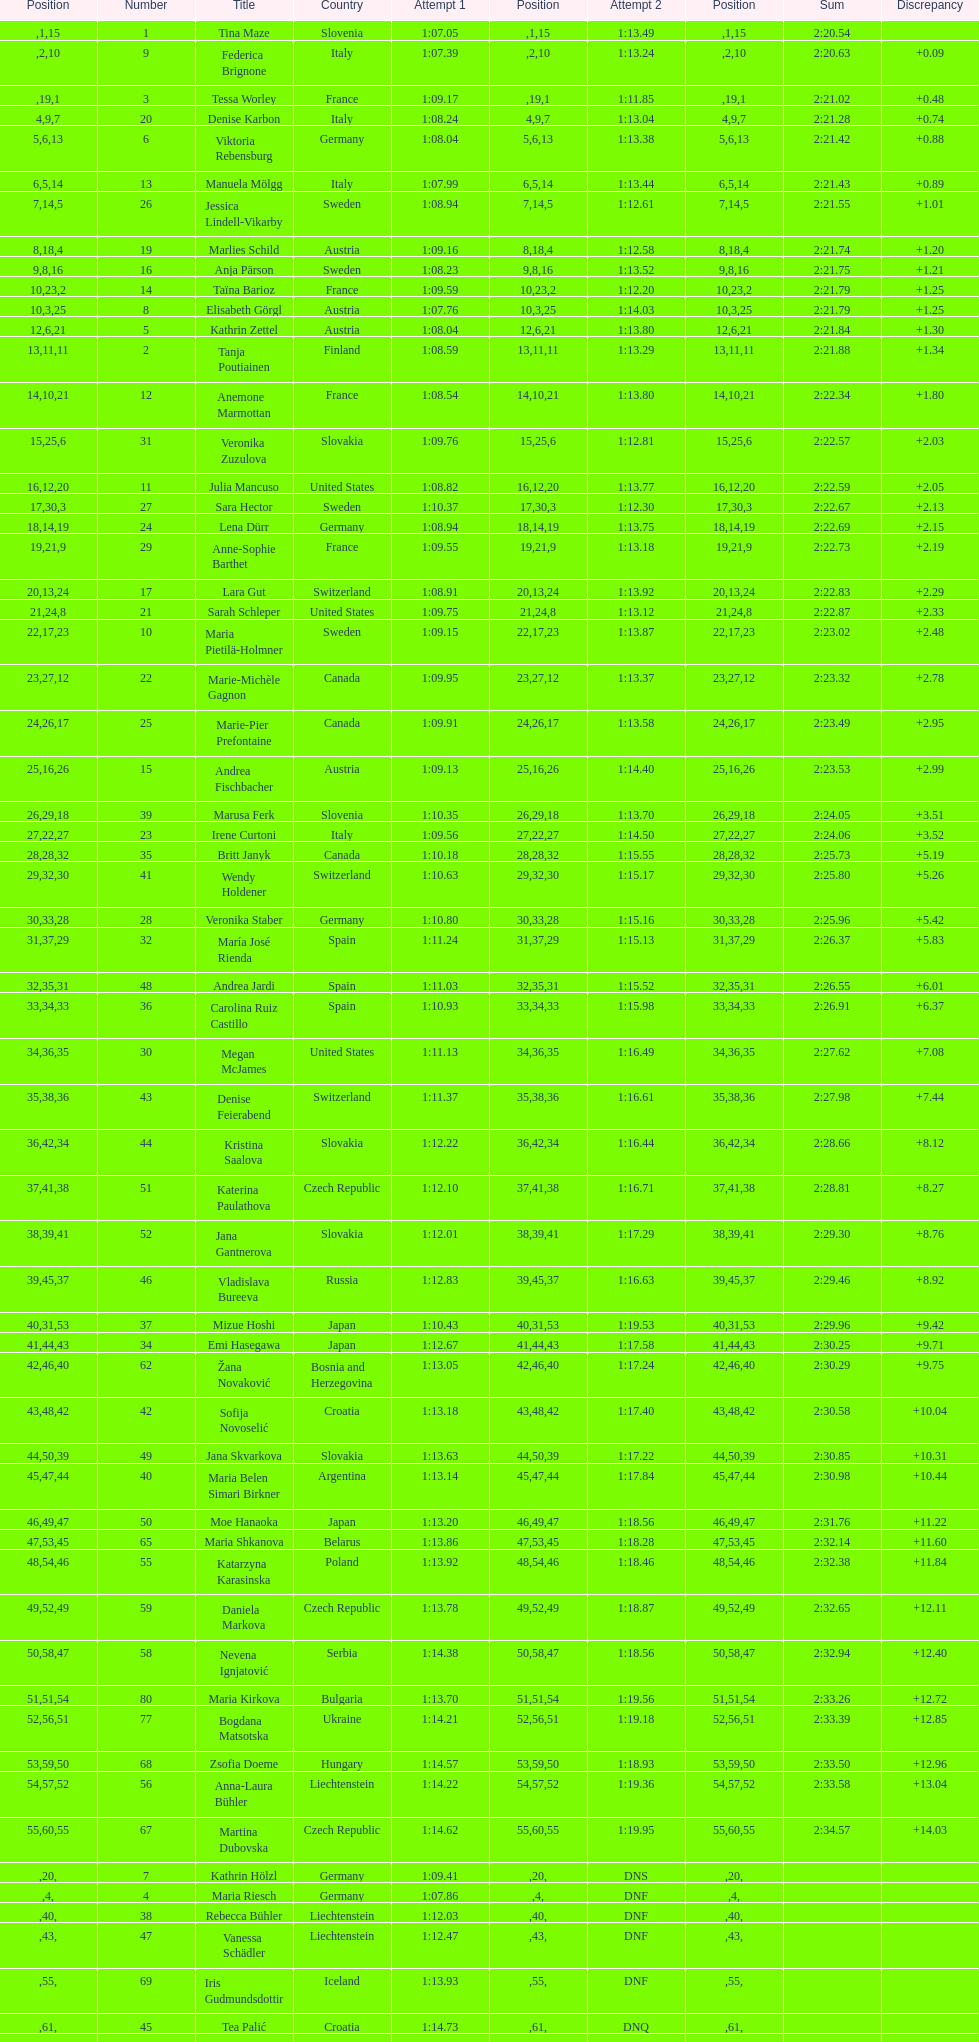How many total names are there? 116. 